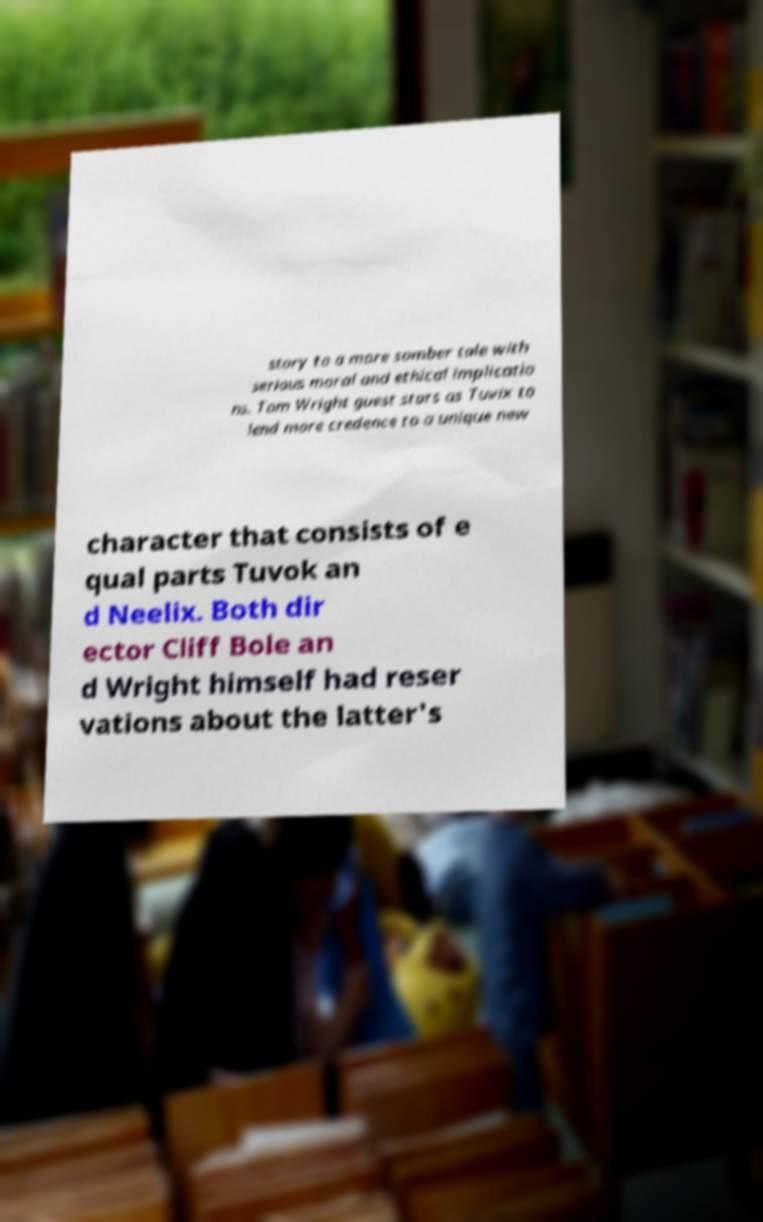For documentation purposes, I need the text within this image transcribed. Could you provide that? story to a more somber tale with serious moral and ethical implicatio ns. Tom Wright guest stars as Tuvix to lend more credence to a unique new character that consists of e qual parts Tuvok an d Neelix. Both dir ector Cliff Bole an d Wright himself had reser vations about the latter's 